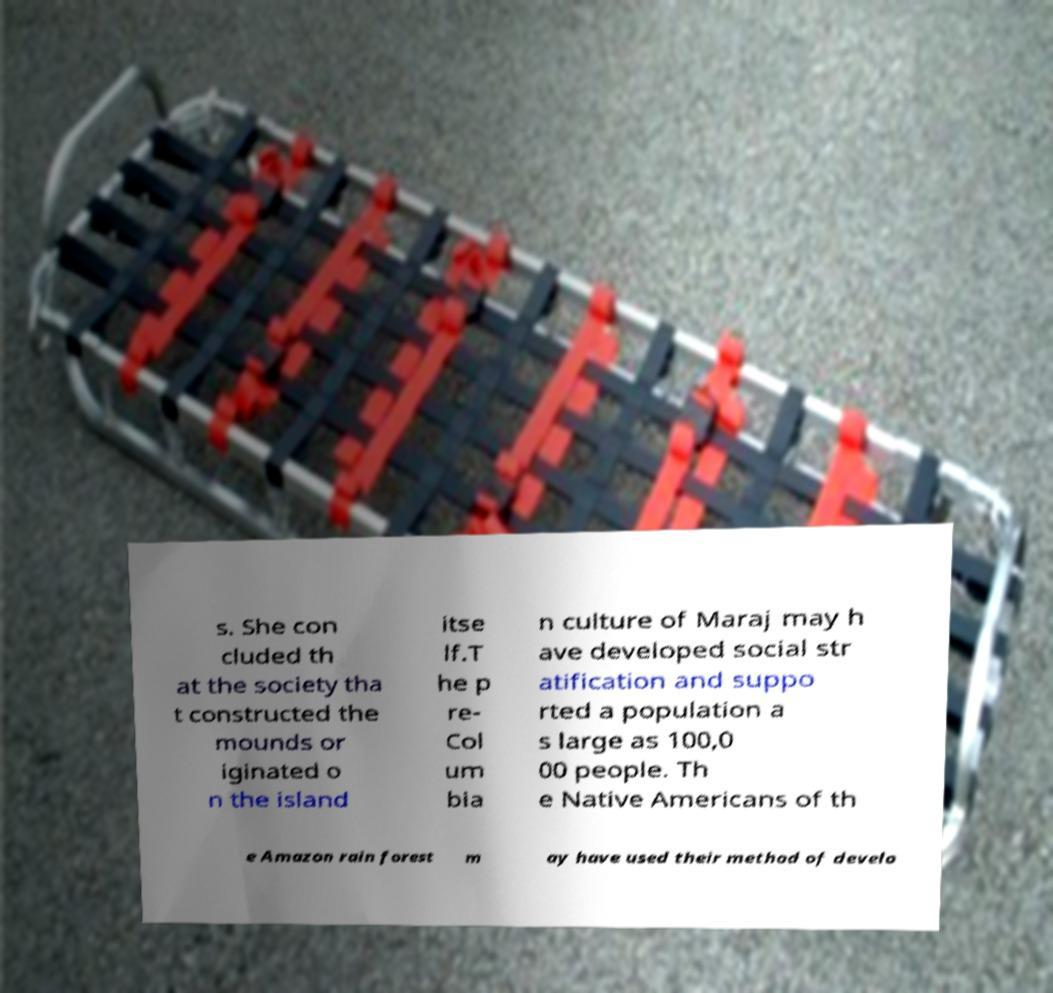I need the written content from this picture converted into text. Can you do that? s. She con cluded th at the society tha t constructed the mounds or iginated o n the island itse lf.T he p re- Col um bia n culture of Maraj may h ave developed social str atification and suppo rted a population a s large as 100,0 00 people. Th e Native Americans of th e Amazon rain forest m ay have used their method of develo 